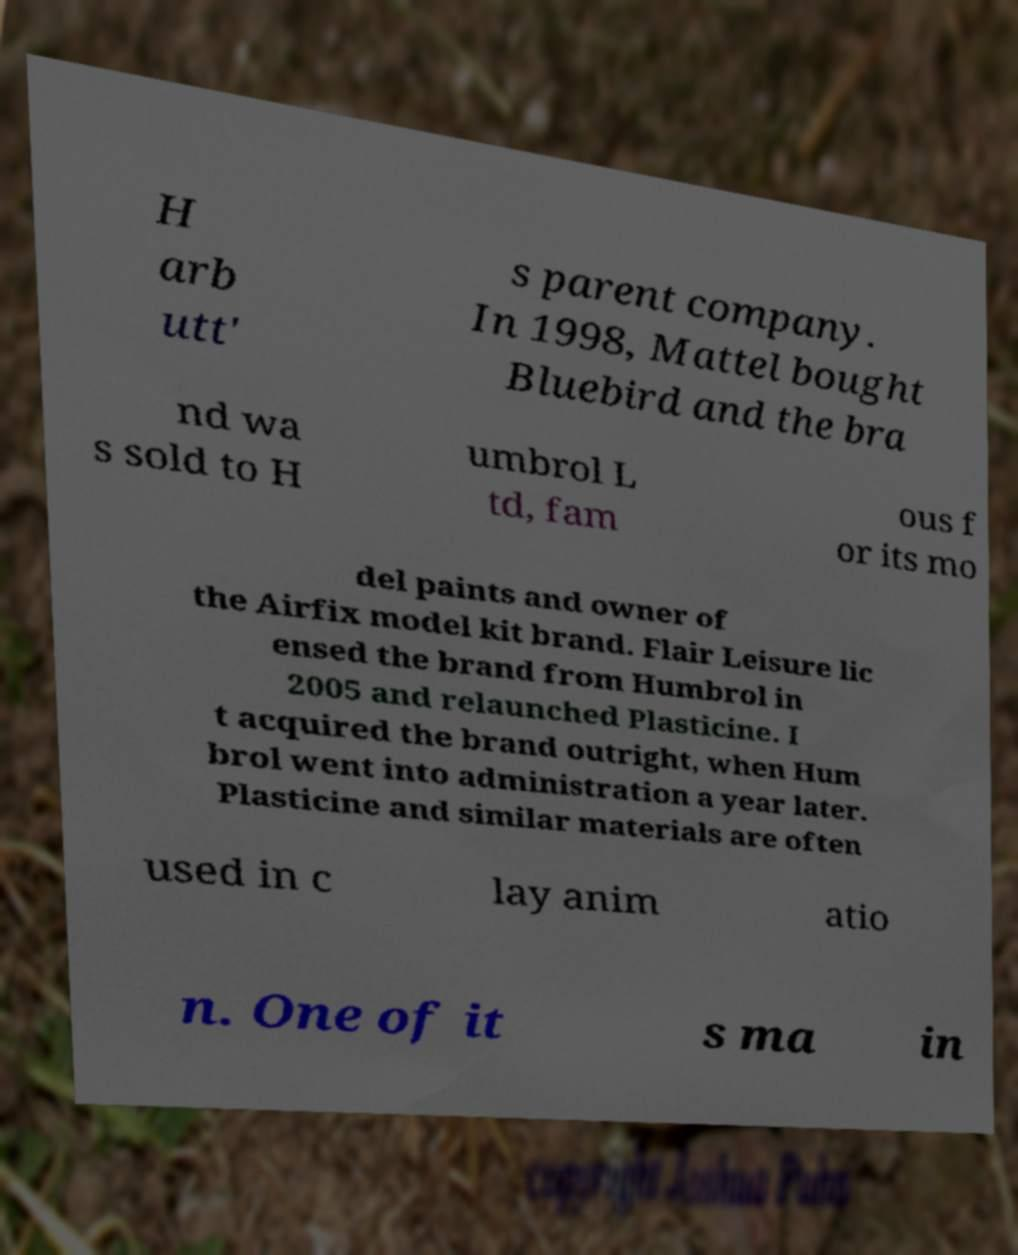Please identify and transcribe the text found in this image. H arb utt' s parent company. In 1998, Mattel bought Bluebird and the bra nd wa s sold to H umbrol L td, fam ous f or its mo del paints and owner of the Airfix model kit brand. Flair Leisure lic ensed the brand from Humbrol in 2005 and relaunched Plasticine. I t acquired the brand outright, when Hum brol went into administration a year later. Plasticine and similar materials are often used in c lay anim atio n. One of it s ma in 